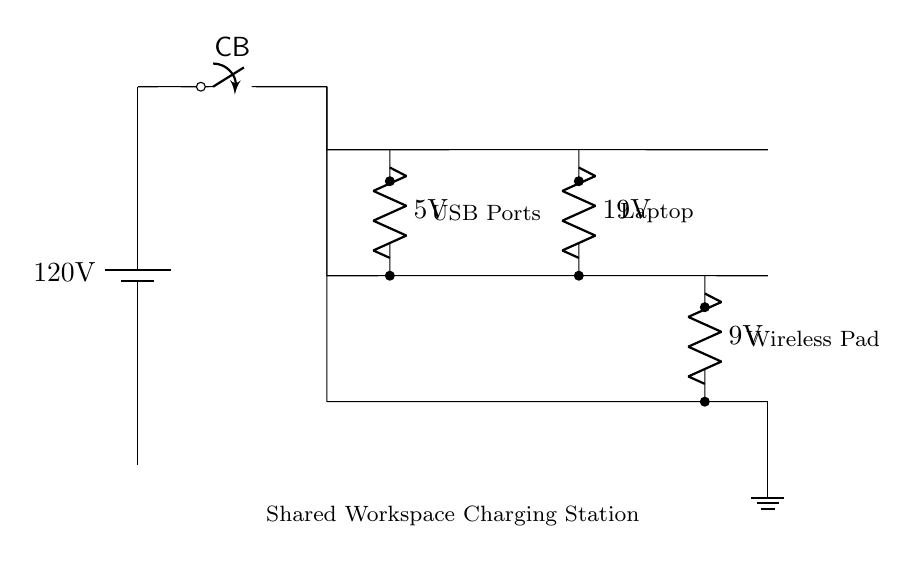What is the main voltage supply for this circuit? The main voltage supply for this circuit is specified at the battery, which shows a label of 120 volts.
Answer: 120 volts What type of devices can be charged at this station? The circuit demonstrates connections for USB ports, a laptop charging station, and a wireless charging pad, indicating that these types of devices can be charged.
Answer: USB ports, laptop, wireless pad How many parallel branches are present in this circuit? The parallel connection is visually depicted by three separate branches extending vertically from a single point, indicating there are three distinct lines for charging.
Answer: Three What voltage is supplied to the laptop charging station? Within the circuit diagram, the laptop charging station is labeled with a voltage of 19 volts. This indicates the specific voltage provided for charging laptops.
Answer: 19 volts If one device draws 2 amperes of current, how would that affect the charging of other devices? In a parallel circuit, each device receives the full voltage supply independently. Therefore, the current drawn by one device (2 amperes) does not affect the voltage supplied to the other devices; they continue to operate at their respective voltages unless total current exceeds the main supply limit.
Answer: Unaffected What is the purpose of the circuit breaker labeled CB? The circuit breaker (labeled CB) is a safety device that interrupts the circuit to protect against overloads or short circuits, ensuring the safety of connected devices in the charging station.
Answer: Safety device 